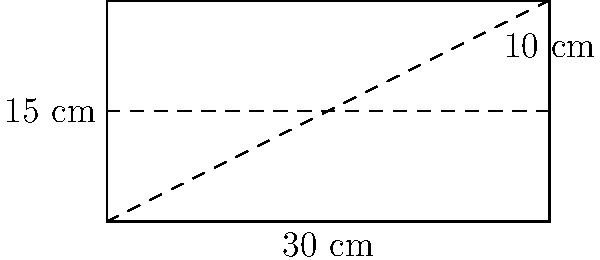A rectangular memory box is being designed to store cherished items. The box has a length of 30 cm and a total height of 15 cm, with a removable tray that sits 10 cm from the bottom. Calculate the total surface area of the box, including the removable tray but excluding the bottom of the box. Let's approach this step-by-step:

1) First, let's identify the dimensions:
   Length = 30 cm
   Width = Not given, let's call it $w$ cm
   Total height = 15 cm
   Height of bottom compartment = 10 cm
   Height of top compartment = 5 cm

2) We need to calculate the surface area of:
   - The outer sides of the box
   - The top of the box
   - The removable tray (both top and bottom)

3) Surface area of outer sides:
   $$ 2(30 \times 15) + 2(w \times 15) = 900 + 30w \text{ cm}^2 $$

4) Surface area of the top:
   $$ 30 \times w \text{ cm}^2 $$

5) Surface area of the removable tray (top and bottom):
   $$ 2(30 \times w) = 60w \text{ cm}^2 $$

6) Total surface area:
   $$ (900 + 30w) + (30w) + (60w) = 900 + 120w \text{ cm}^2 $$

7) The final answer is in terms of $w$ because the width wasn't specified in the question.
Answer: $900 + 120w \text{ cm}^2$, where $w$ is the width of the box in cm 